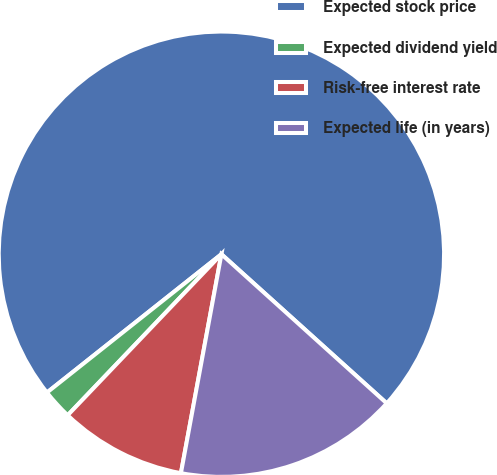Convert chart to OTSL. <chart><loc_0><loc_0><loc_500><loc_500><pie_chart><fcel>Expected stock price<fcel>Expected dividend yield<fcel>Risk-free interest rate<fcel>Expected life (in years)<nl><fcel>72.35%<fcel>2.2%<fcel>9.22%<fcel>16.23%<nl></chart> 